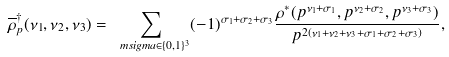Convert formula to latex. <formula><loc_0><loc_0><loc_500><loc_500>\overline { \rho } ^ { \dagger } _ { p } ( \nu _ { 1 } , \nu _ { 2 } , \nu _ { 3 } ) = \sum _ { \ m s i g m a \in \{ 0 , 1 \} ^ { 3 } } ( - 1 ) ^ { \sigma _ { 1 } + \sigma _ { 2 } + \sigma _ { 3 } } \frac { \rho ^ { * } ( p ^ { \nu _ { 1 } + \sigma _ { 1 } } , p ^ { \nu _ { 2 } + \sigma _ { 2 } } , p ^ { \nu _ { 3 } + \sigma _ { 3 } } ) } { p ^ { 2 ( \nu _ { 1 } + \nu _ { 2 } + \nu _ { 3 } + \sigma _ { 1 } + \sigma _ { 2 } + \sigma _ { 3 } ) } } ,</formula> 